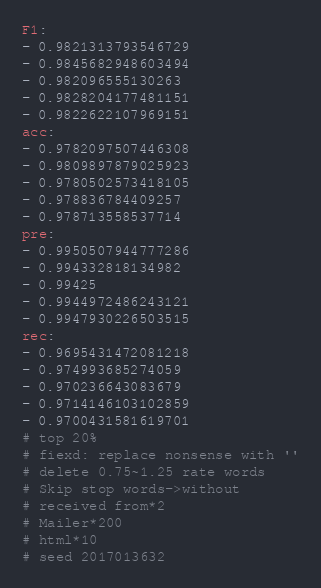Convert code to text. <code><loc_0><loc_0><loc_500><loc_500><_YAML_>F1:
- 0.9821313793546729
- 0.9845682948603494
- 0.982096555130263
- 0.9828204177481151
- 0.9822622107969151
acc:
- 0.9782097507446308
- 0.9809897879025923
- 0.9780502573418105
- 0.978836784409257
- 0.978713558537714
pre:
- 0.9950507944777286
- 0.994332818134982
- 0.99425
- 0.9944972486243121
- 0.9947930226503515
rec:
- 0.9695431472081218
- 0.974993685274059
- 0.970236643083679
- 0.9714146103102859
- 0.9700431581619701
# top 20% 
# fiexd: replace nonsense with ''
# delete 0.75~1.25 rate words
# Skip stop words->without
# received from*2
# Mailer*200
# html*10
# seed 2017013632</code> 